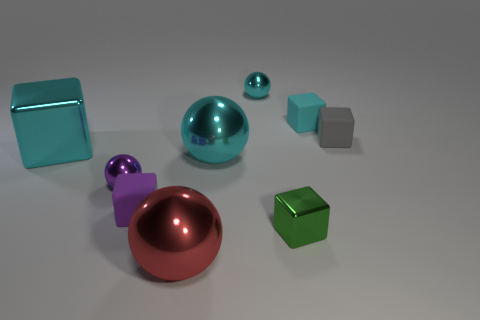What color is the large cube that is to the left of the cyan thing right of the small ball that is behind the gray block?
Offer a terse response. Cyan. The sphere that is the same size as the red shiny object is what color?
Provide a short and direct response. Cyan. What number of matte things are balls or cubes?
Give a very brief answer. 3. There is a big block that is made of the same material as the green thing; what color is it?
Provide a short and direct response. Cyan. What is the material of the cyan thing that is in front of the shiny cube that is behind the small green thing?
Provide a succinct answer. Metal. How many objects are either objects behind the small purple rubber cube or cyan blocks that are on the left side of the tiny cyan block?
Provide a short and direct response. 6. What size is the cyan shiny object to the left of the sphere that is in front of the small metallic block that is in front of the gray matte object?
Provide a short and direct response. Large. Is the number of tiny metallic objects to the right of the purple ball the same as the number of gray rubber objects?
Offer a very short reply. No. Is there anything else that is the same shape as the cyan rubber thing?
Provide a succinct answer. Yes. There is a purple matte object; does it have the same shape as the rubber object behind the gray matte block?
Offer a terse response. Yes. 